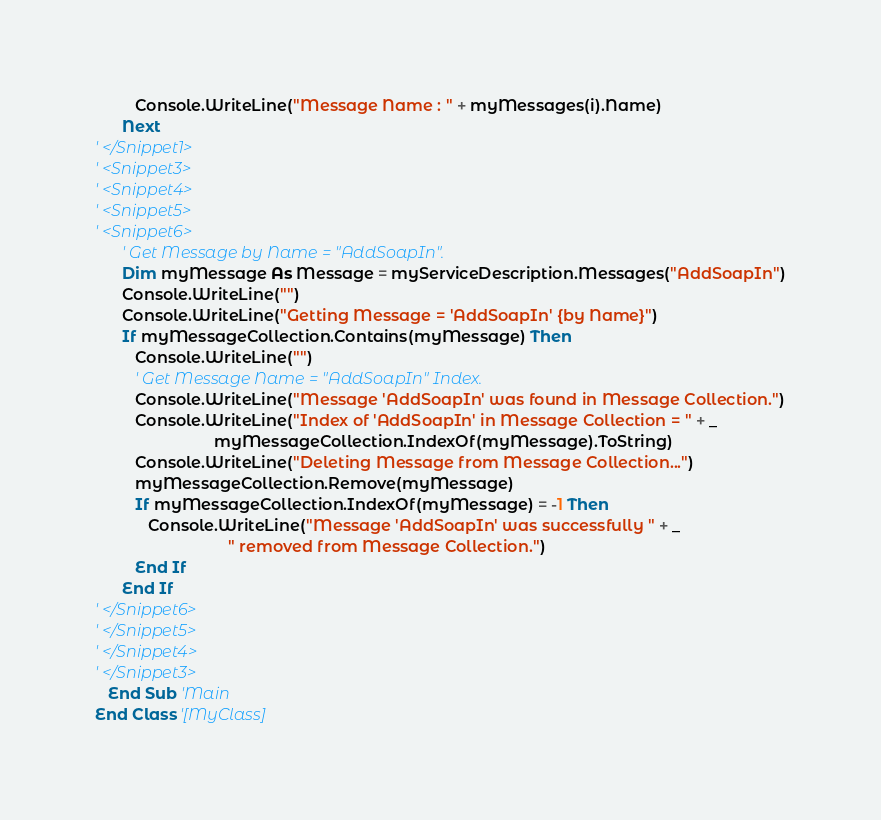Convert code to text. <code><loc_0><loc_0><loc_500><loc_500><_VisualBasic_>         Console.WriteLine("Message Name : " + myMessages(i).Name)
      Next
' </Snippet1>
' <Snippet3>
' <Snippet4>
' <Snippet5>
' <Snippet6>
      ' Get Message by Name = "AddSoapIn".
      Dim myMessage As Message = myServiceDescription.Messages("AddSoapIn")
      Console.WriteLine("")
      Console.WriteLine("Getting Message = 'AddSoapIn' {by Name}")
      If myMessageCollection.Contains(myMessage) Then
         Console.WriteLine("")
         ' Get Message Name = "AddSoapIn" Index.
         Console.WriteLine("Message 'AddSoapIn' was found in Message Collection.")
         Console.WriteLine("Index of 'AddSoapIn' in Message Collection = " + _
                           myMessageCollection.IndexOf(myMessage).ToString)
         Console.WriteLine("Deleting Message from Message Collection...")
         myMessageCollection.Remove(myMessage)
         If myMessageCollection.IndexOf(myMessage) = -1 Then
            Console.WriteLine("Message 'AddSoapIn' was successfully " + _
                              " removed from Message Collection.")
         End If
      End If
' </Snippet6>
' </Snippet5>
' </Snippet4>
' </Snippet3>
   End Sub 'Main
End Class '[MyClass]
</code> 